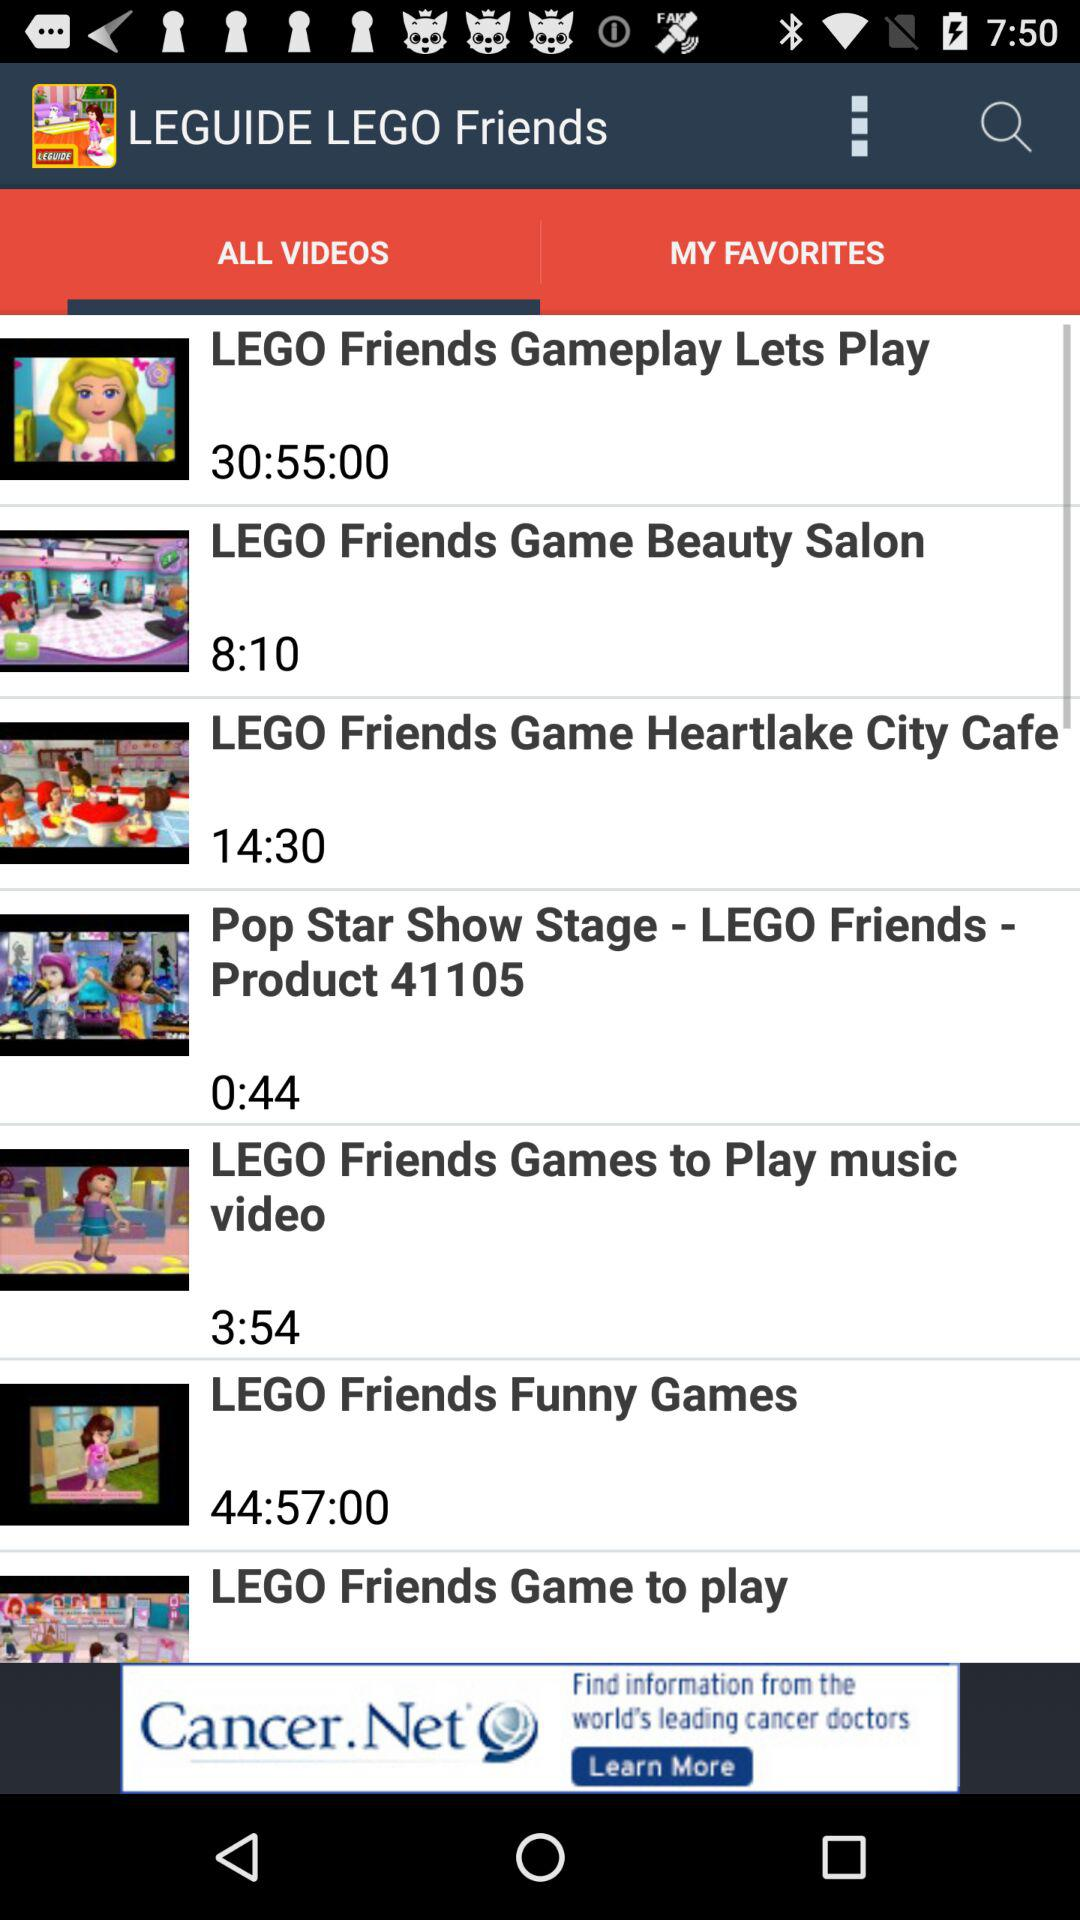Which tab is currently selected? The tab "ALL VIDEOS" is currently selected. 